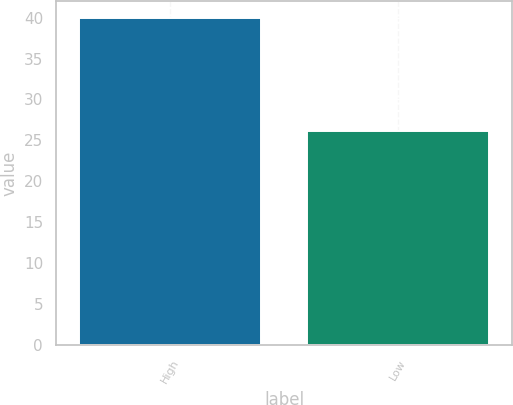<chart> <loc_0><loc_0><loc_500><loc_500><bar_chart><fcel>High<fcel>Low<nl><fcel>40<fcel>26.14<nl></chart> 